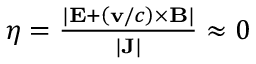<formula> <loc_0><loc_0><loc_500><loc_500>\begin{array} { r } { \eta = \frac { | E + \left ( v / c \right ) \times B | } { | J | } \approx 0 } \end{array}</formula> 